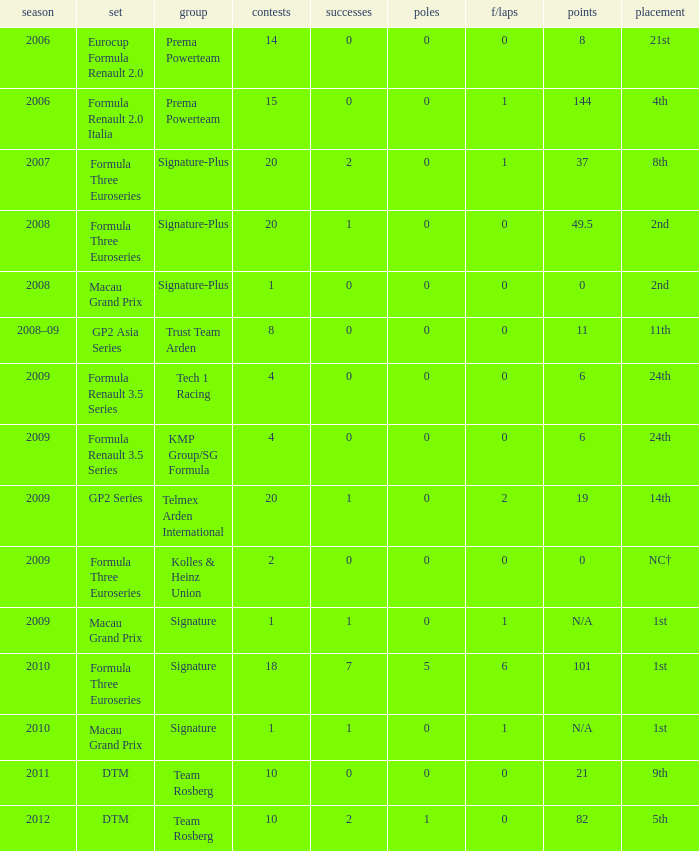How many races did the Formula Three Euroseries signature team have? 18.0. 